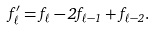Convert formula to latex. <formula><loc_0><loc_0><loc_500><loc_500>f ^ { \prime } _ { \ell } = f _ { \ell } - 2 f _ { \ell - 1 } + f _ { \ell - 2 } .</formula> 